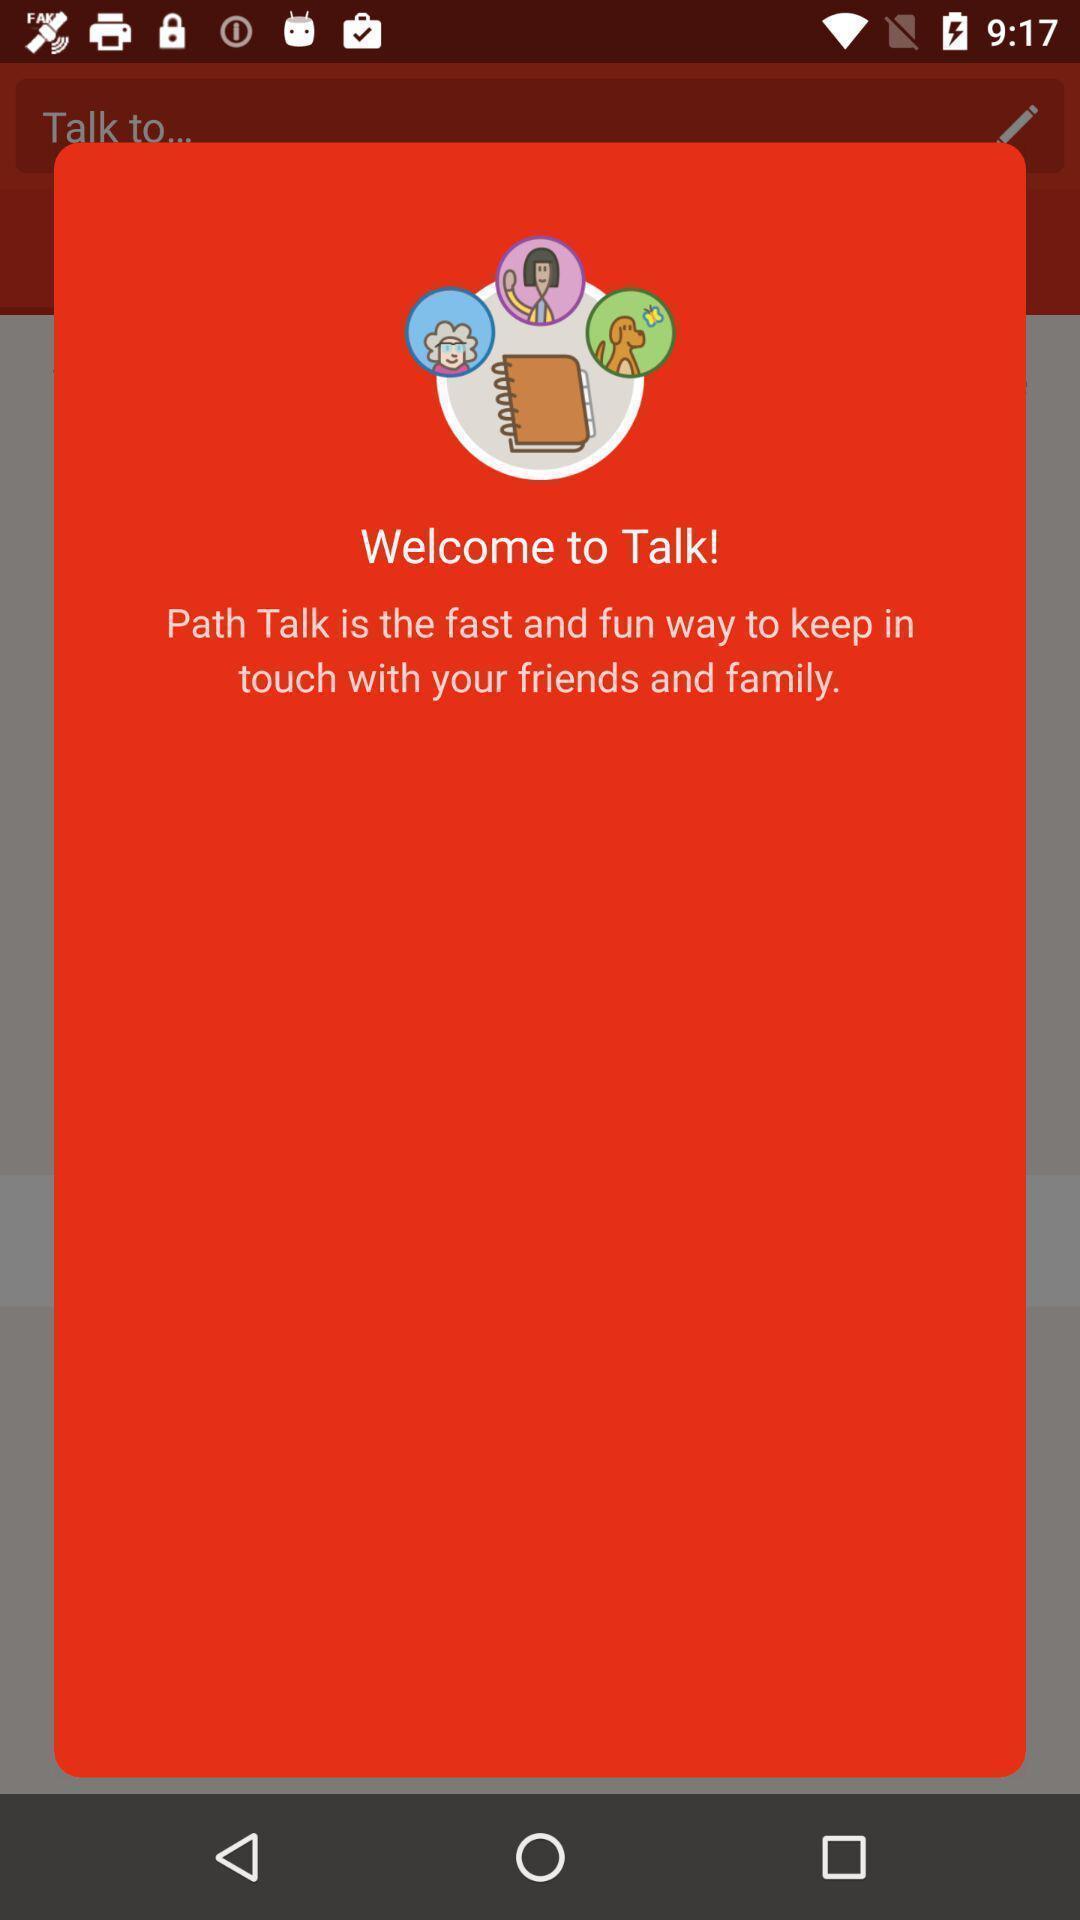Describe the key features of this screenshot. Welcome page of a chatting app. 